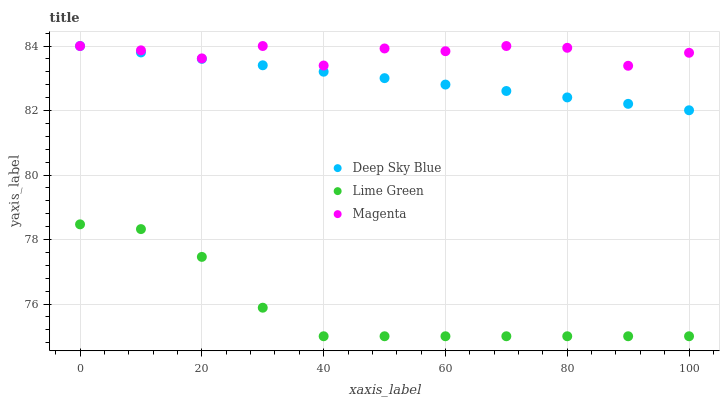Does Lime Green have the minimum area under the curve?
Answer yes or no. Yes. Does Magenta have the maximum area under the curve?
Answer yes or no. Yes. Does Deep Sky Blue have the minimum area under the curve?
Answer yes or no. No. Does Deep Sky Blue have the maximum area under the curve?
Answer yes or no. No. Is Deep Sky Blue the smoothest?
Answer yes or no. Yes. Is Magenta the roughest?
Answer yes or no. Yes. Is Lime Green the smoothest?
Answer yes or no. No. Is Lime Green the roughest?
Answer yes or no. No. Does Lime Green have the lowest value?
Answer yes or no. Yes. Does Deep Sky Blue have the lowest value?
Answer yes or no. No. Does Deep Sky Blue have the highest value?
Answer yes or no. Yes. Does Lime Green have the highest value?
Answer yes or no. No. Is Lime Green less than Magenta?
Answer yes or no. Yes. Is Deep Sky Blue greater than Lime Green?
Answer yes or no. Yes. Does Deep Sky Blue intersect Magenta?
Answer yes or no. Yes. Is Deep Sky Blue less than Magenta?
Answer yes or no. No. Is Deep Sky Blue greater than Magenta?
Answer yes or no. No. Does Lime Green intersect Magenta?
Answer yes or no. No. 